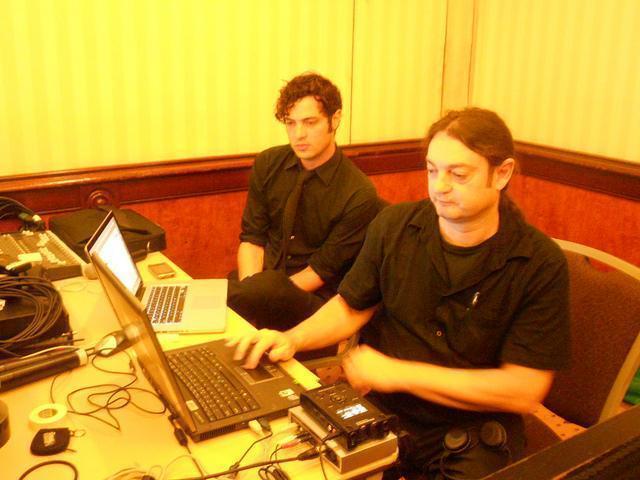Why is he looking at the other guy's laptop?
Pick the correct solution from the four options below to address the question.
Options: Is curious, is teaching, stealing information, is learning. Is learning. 